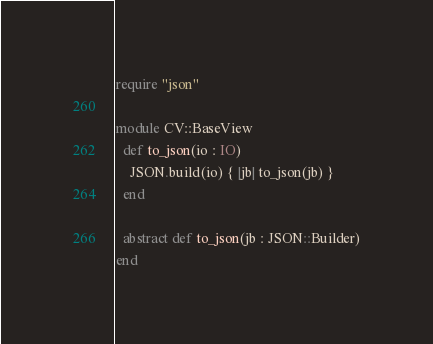<code> <loc_0><loc_0><loc_500><loc_500><_Crystal_>require "json"

module CV::BaseView
  def to_json(io : IO)
    JSON.build(io) { |jb| to_json(jb) }
  end

  abstract def to_json(jb : JSON::Builder)
end
</code> 